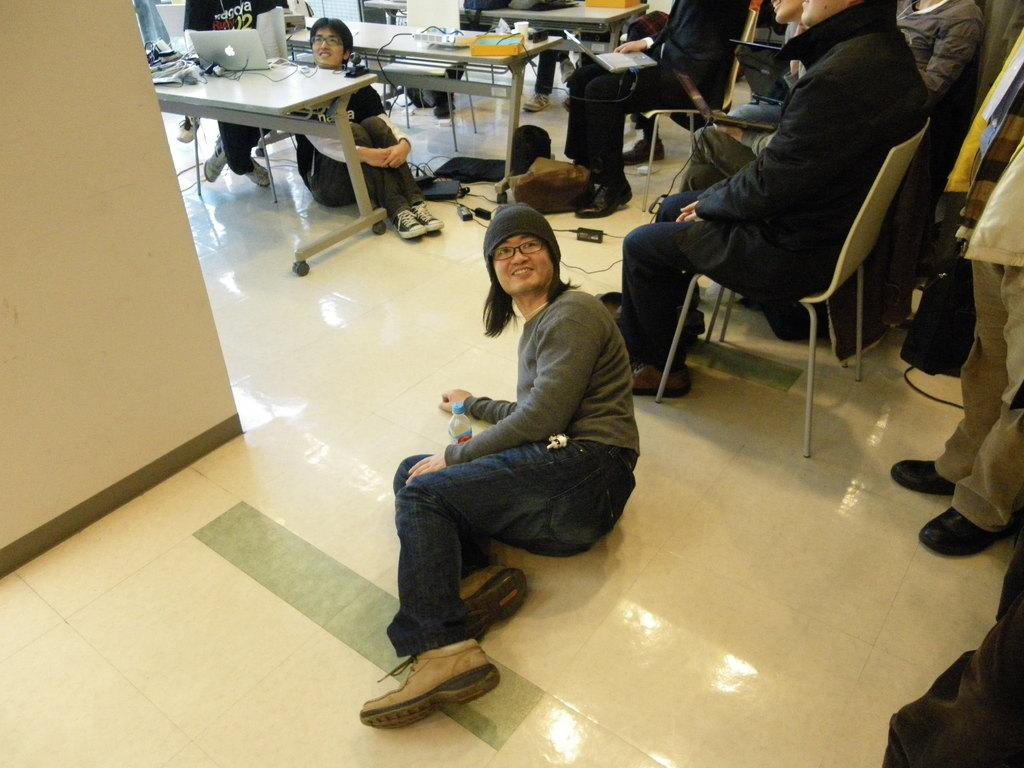What are the people in the image doing? The people in the image are sitting on chairs and on the ground. What type of furniture is present in the image? There are chairs and tables in the image. What can be found on the tables in the image? There are objects on the tables in the image. What type of string is being used to create a boundary in the image? There is no string or boundary present in the image. What type of yarn is being used by the people in the image? There is no yarn visible in the image; the people are simply sitting on chairs and the ground. 